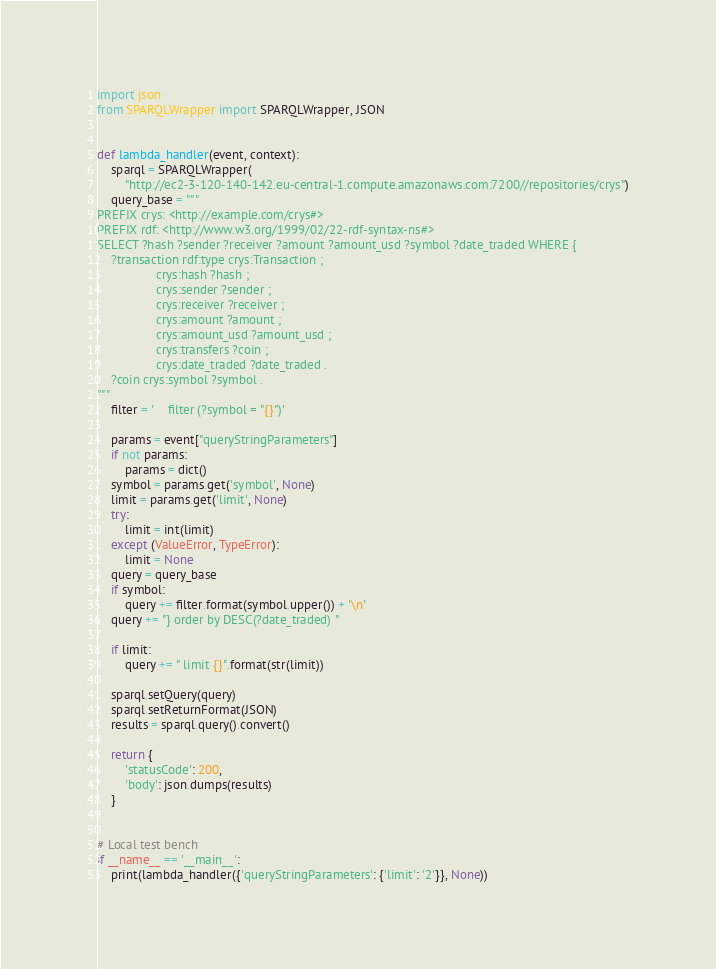<code> <loc_0><loc_0><loc_500><loc_500><_Python_>import json
from SPARQLWrapper import SPARQLWrapper, JSON


def lambda_handler(event, context):
    sparql = SPARQLWrapper(
        "http://ec2-3-120-140-142.eu-central-1.compute.amazonaws.com:7200//repositories/crys")
    query_base = """
PREFIX crys: <http://example.com/crys#>
PREFIX rdf: <http://www.w3.org/1999/02/22-rdf-syntax-ns#>
SELECT ?hash ?sender ?receiver ?amount ?amount_usd ?symbol ?date_traded WHERE {
    ?transaction rdf:type crys:Transaction ;
                 crys:hash ?hash ;
                 crys:sender ?sender ;
                 crys:receiver ?receiver ;
                 crys:amount ?amount ;
                 crys:amount_usd ?amount_usd ;
                 crys:transfers ?coin ;
                 crys:date_traded ?date_traded .
    ?coin crys:symbol ?symbol .           
"""
    filter = '    filter (?symbol = "{}")'

    params = event["queryStringParameters"]
    if not params:
        params = dict()
    symbol = params.get('symbol', None)
    limit = params.get('limit', None)
    try:
        limit = int(limit)
    except (ValueError, TypeError):
        limit = None
    query = query_base
    if symbol:
        query += filter.format(symbol.upper()) + '\n'
    query += "} order by DESC(?date_traded) "

    if limit:
        query += " limit {}".format(str(limit))

    sparql.setQuery(query)
    sparql.setReturnFormat(JSON)
    results = sparql.query().convert()

    return {
        'statusCode': 200,
        'body': json.dumps(results)
    }


# Local test bench
if __name__ == '__main__':
    print(lambda_handler({'queryStringParameters': {'limit': '2'}}, None))
</code> 